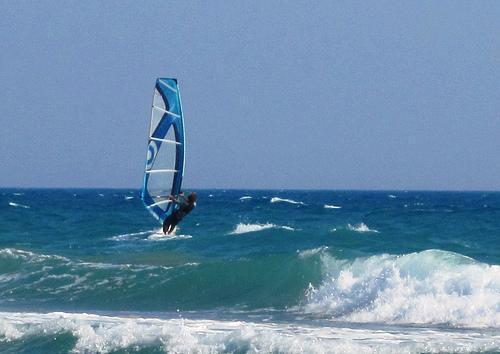How many people are in this picture?
Give a very brief answer. 1. 